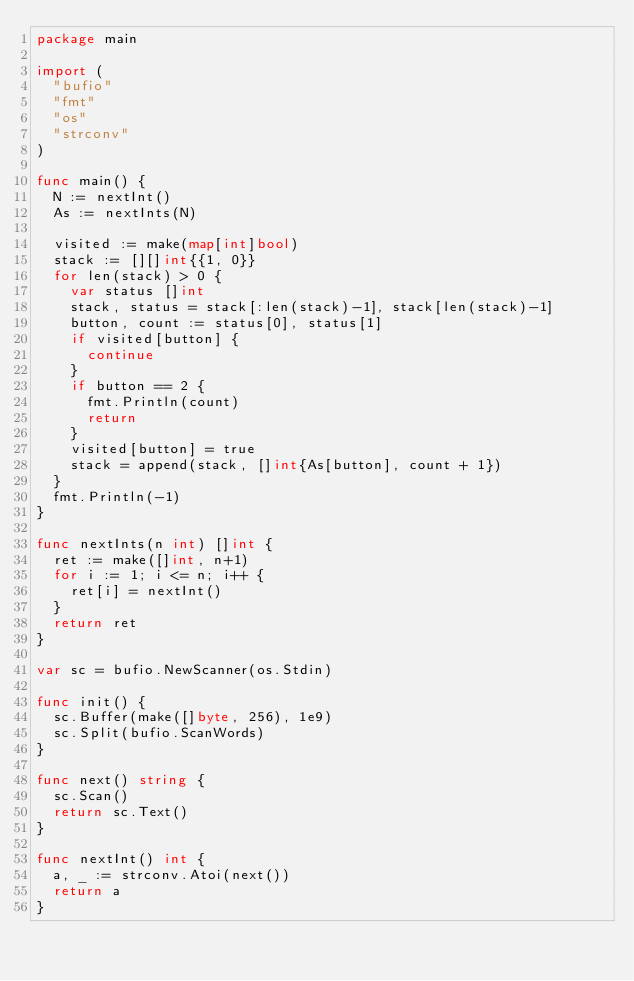<code> <loc_0><loc_0><loc_500><loc_500><_Go_>package main

import (
	"bufio"
	"fmt"
	"os"
	"strconv"
)

func main() {
	N := nextInt()
	As := nextInts(N)

	visited := make(map[int]bool)
	stack := [][]int{{1, 0}}
	for len(stack) > 0 {
		var status []int
		stack, status = stack[:len(stack)-1], stack[len(stack)-1]
		button, count := status[0], status[1]
		if visited[button] {
			continue
		}
		if button == 2 {
			fmt.Println(count)
			return
		}
		visited[button] = true
		stack = append(stack, []int{As[button], count + 1})
	}
	fmt.Println(-1)
}

func nextInts(n int) []int {
	ret := make([]int, n+1)
	for i := 1; i <= n; i++ {
		ret[i] = nextInt()
	}
	return ret
}

var sc = bufio.NewScanner(os.Stdin)

func init() {
	sc.Buffer(make([]byte, 256), 1e9)
	sc.Split(bufio.ScanWords)
}

func next() string {
	sc.Scan()
	return sc.Text()
}

func nextInt() int {
	a, _ := strconv.Atoi(next())
	return a
}
</code> 